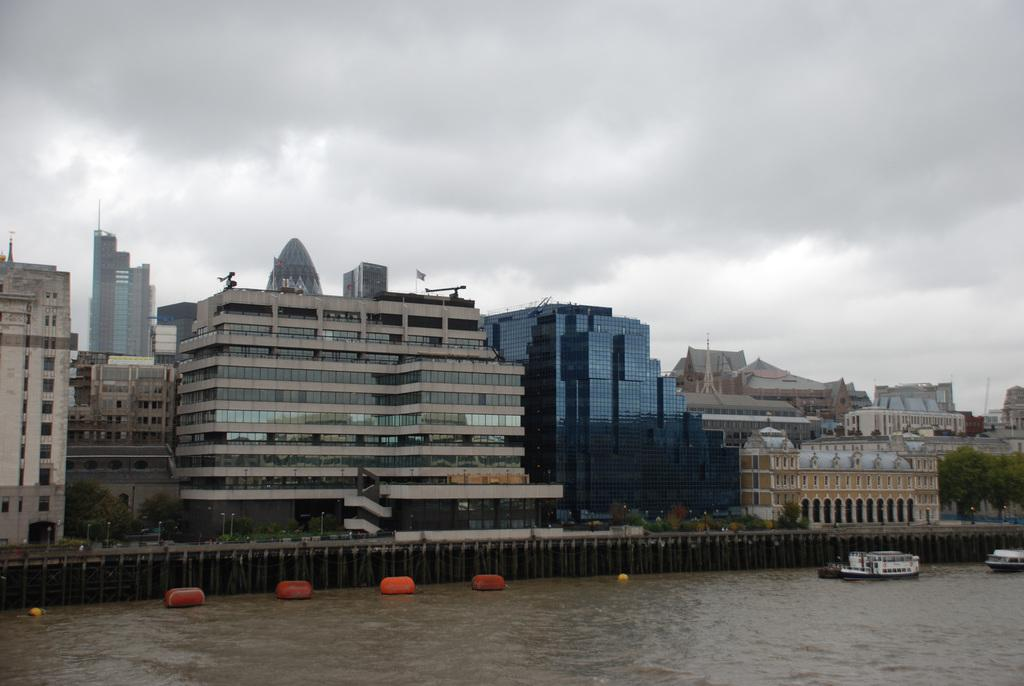What is present on the river in the image? There are boats and tubes on the river in the image. What can be seen in the background of the image? There are trees, buildings, and the sky visible in the background of the image. Where is the grandmother sitting with her sponge and cracker in the image? There is no grandmother, sponge, or cracker present in the image. 